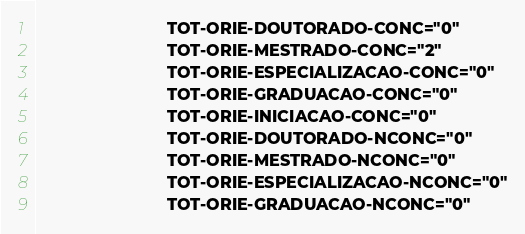<code> <loc_0><loc_0><loc_500><loc_500><_XML_>                            TOT-ORIE-DOUTORADO-CONC="0"
                            TOT-ORIE-MESTRADO-CONC="2"
                            TOT-ORIE-ESPECIALIZACAO-CONC="0"
                            TOT-ORIE-GRADUACAO-CONC="0"
                            TOT-ORIE-INICIACAO-CONC="0"
                            TOT-ORIE-DOUTORADO-NCONC="0"
                            TOT-ORIE-MESTRADO-NCONC="0"
                            TOT-ORIE-ESPECIALIZACAO-NCONC="0"
                            TOT-ORIE-GRADUACAO-NCONC="0"</code> 